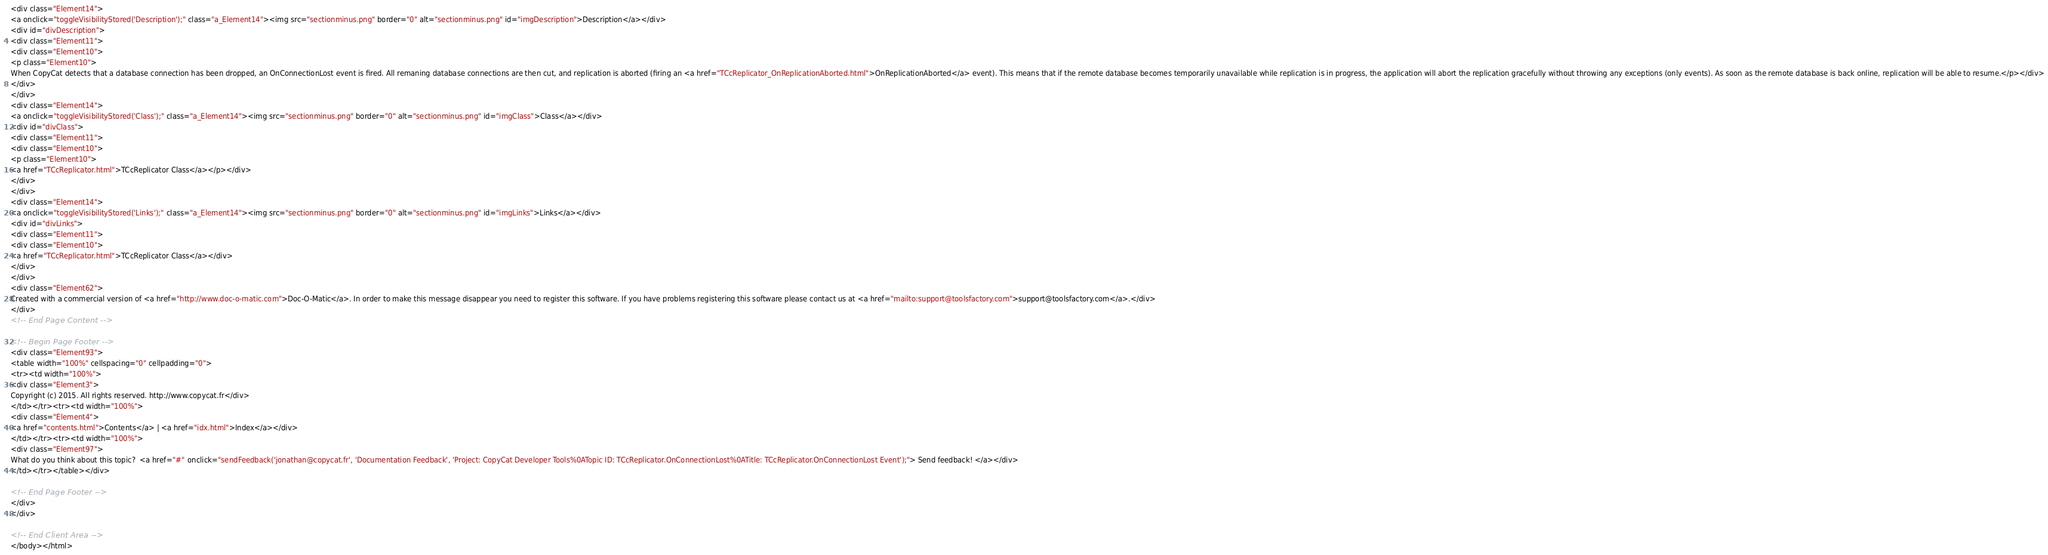<code> <loc_0><loc_0><loc_500><loc_500><_HTML_><div class="Element14">
<a onclick="toggleVisibilityStored('Description');" class="a_Element14"><img src="sectionminus.png" border="0" alt="sectionminus.png" id="imgDescription">Description</a></div>
<div id="divDescription">
<div class="Element11">
<div class="Element10">
<p class="Element10">
When CopyCat detects that a database connection has been dropped, an OnConnectionLost event is fired. All remaning database connections are then cut, and replication is aborted (firing an <a href="TCcReplicator_OnReplicationAborted.html">OnReplicationAborted</a> event). This means that if the remote database becomes temporarily unavailable while replication is in progress, the application will abort the replication gracefully without throwing any exceptions (only events). As soon as the remote database is back online, replication will be able to resume.</p></div>
</div>
</div>
<div class="Element14">
<a onclick="toggleVisibilityStored('Class');" class="a_Element14"><img src="sectionminus.png" border="0" alt="sectionminus.png" id="imgClass">Class</a></div>
<div id="divClass">
<div class="Element11">
<div class="Element10">
<p class="Element10">
<a href="TCcReplicator.html">TCcReplicator Class</a></p></div>
</div>
</div>
<div class="Element14">
<a onclick="toggleVisibilityStored('Links');" class="a_Element14"><img src="sectionminus.png" border="0" alt="sectionminus.png" id="imgLinks">Links</a></div>
<div id="divLinks">
<div class="Element11">
<div class="Element10">
<a href="TCcReplicator.html">TCcReplicator Class</a></div>
</div>
</div>
<div class="Element62">
Created with a commercial version of <a href="http://www.doc-o-matic.com">Doc-O-Matic</a>. In order to make this message disappear you need to register this software. If you have problems registering this software please contact us at <a href="mailto:support@toolsfactory.com">support@toolsfactory.com</a>.</div>
</div>
<!-- End Page Content -->

<!-- Begin Page Footer -->
<div class="Element93">
<table width="100%" cellspacing="0" cellpadding="0">
<tr><td width="100%">
<div class="Element3">
Copyright (c) 2015. All rights reserved. http://www.copycat.fr</div>
</td></tr><tr><td width="100%">
<div class="Element4">
<a href="contents.html">Contents</a> | <a href="idx.html">Index</a></div>
</td></tr><tr><td width="100%">
<div class="Element97">
What do you think about this topic?  <a href="#" onclick="sendFeedback('jonathan@copycat.fr', 'Documentation Feedback', 'Project: CopyCat Developer Tools%0ATopic ID: TCcReplicator.OnConnectionLost%0ATitle: TCcReplicator.OnConnectionLost Event');"> Send feedback! </a></div>
</td></tr></table></div>

<!-- End Page Footer -->
</div>
</div>

<!-- End Client Area -->
</body></html></code> 